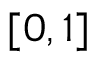Convert formula to latex. <formula><loc_0><loc_0><loc_500><loc_500>[ 0 , 1 ]</formula> 